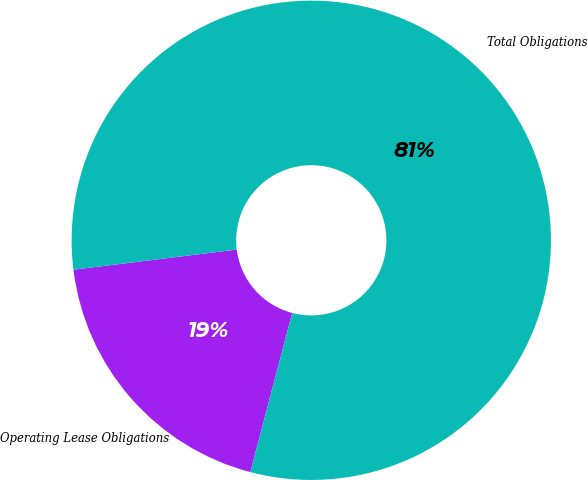Convert chart. <chart><loc_0><loc_0><loc_500><loc_500><pie_chart><fcel>Operating Lease Obligations<fcel>Total Obligations<nl><fcel>18.95%<fcel>81.05%<nl></chart> 